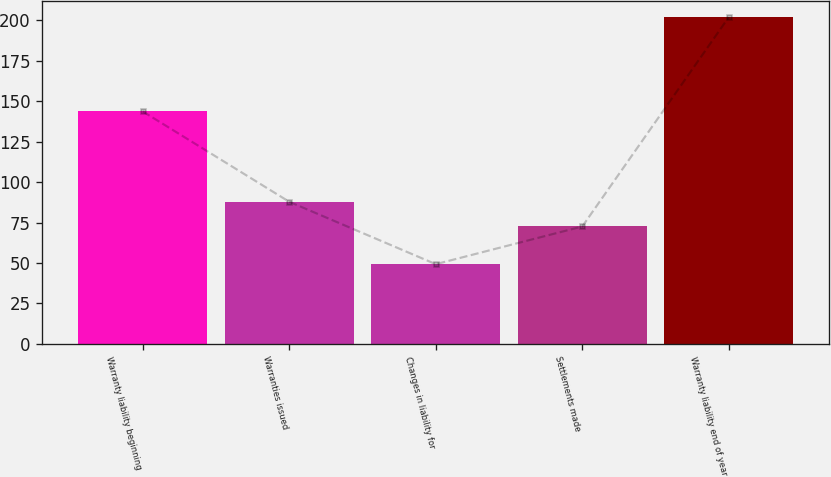Convert chart to OTSL. <chart><loc_0><loc_0><loc_500><loc_500><bar_chart><fcel>Warranty liability beginning<fcel>Warranties issued<fcel>Changes in liability for<fcel>Settlements made<fcel>Warranty liability end of year<nl><fcel>143.7<fcel>87.87<fcel>49.3<fcel>72.6<fcel>202<nl></chart> 